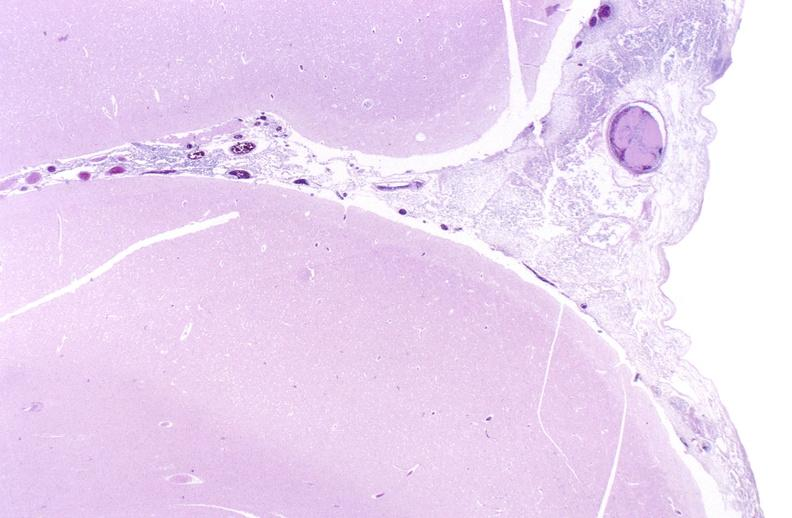what is present?
Answer the question using a single word or phrase. Nervous 